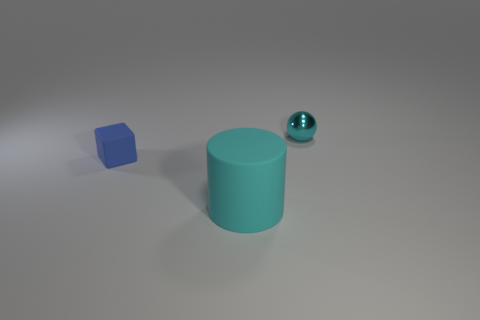Is there anything else that is the same shape as the large cyan object?
Offer a terse response. No. How many other objects are there of the same color as the cylinder?
Make the answer very short. 1. There is a metal thing that is the same size as the blue cube; what is its shape?
Ensure brevity in your answer.  Sphere. There is a small object that is left of the cyan metallic sphere; what is its color?
Offer a very short reply. Blue. How many things are either objects on the left side of the cyan metal ball or big cylinders left of the cyan sphere?
Provide a succinct answer. 2. Is the size of the cyan metal thing the same as the cylinder?
Your answer should be compact. No. What number of cylinders are blue things or matte things?
Give a very brief answer. 1. What number of objects are behind the big cyan object and in front of the ball?
Make the answer very short. 1. There is a blue rubber thing; is it the same size as the cyan cylinder that is in front of the tiny rubber block?
Offer a very short reply. No. Are there any small objects on the right side of the small thing that is to the left of the small object that is on the right side of the cyan matte cylinder?
Your answer should be very brief. Yes. 